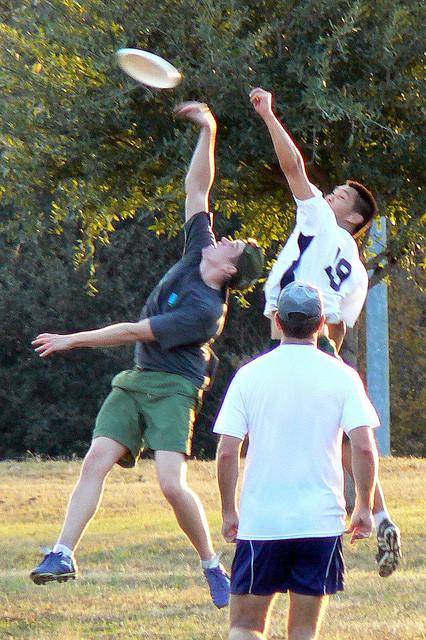Is it summer?
Write a very short answer. Yes. What type of sport are the men playing?
Concise answer only. Frisbee. How many players are in the air?
Be succinct. 2. 